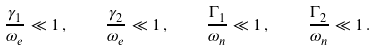<formula> <loc_0><loc_0><loc_500><loc_500>\frac { \gamma _ { 1 } } { \omega _ { e } } \ll 1 \, , \quad \frac { \gamma _ { 2 } } { \omega _ { e } } \ll 1 \, , \quad \frac { \Gamma _ { 1 } } { \omega _ { n } } \ll 1 \, , \quad \frac { \Gamma _ { 2 } } { \omega _ { n } } \ll 1 \, .</formula> 